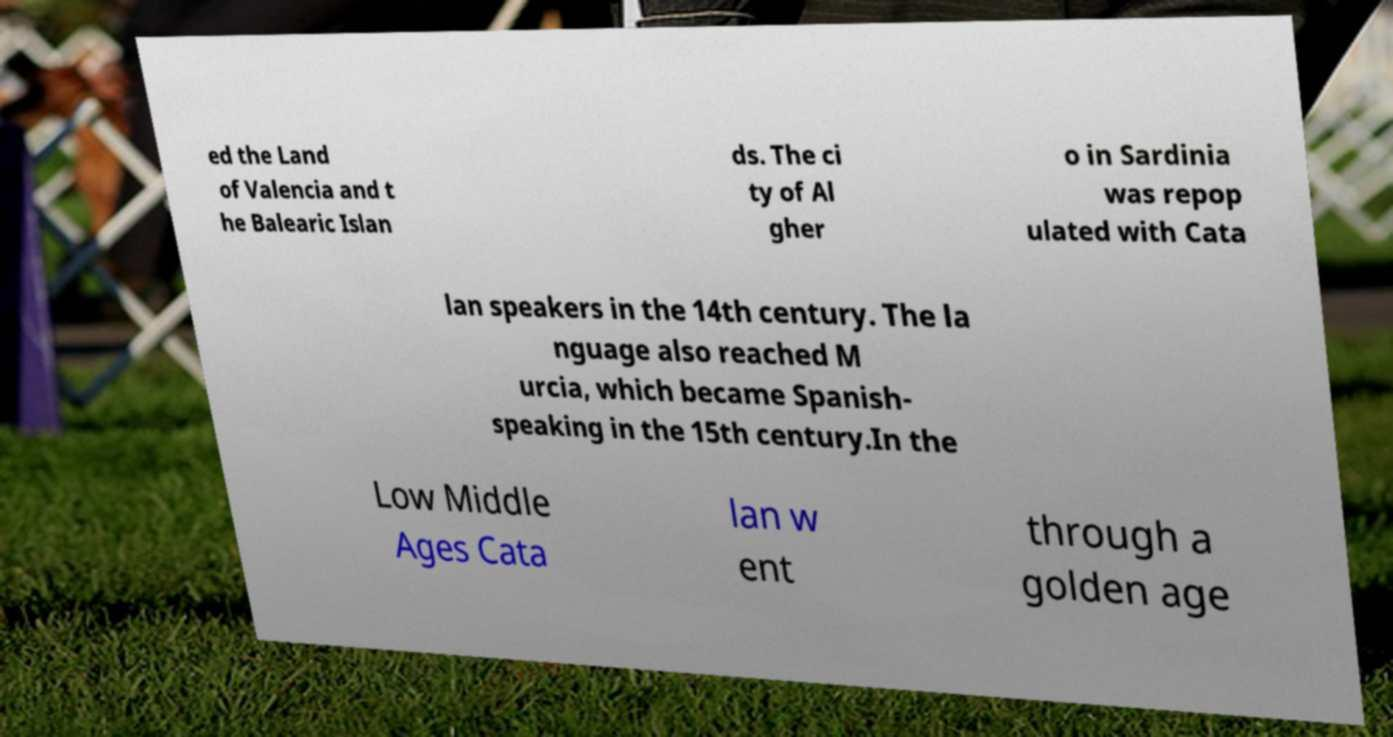Could you extract and type out the text from this image? ed the Land of Valencia and t he Balearic Islan ds. The ci ty of Al gher o in Sardinia was repop ulated with Cata lan speakers in the 14th century. The la nguage also reached M urcia, which became Spanish- speaking in the 15th century.In the Low Middle Ages Cata lan w ent through a golden age 